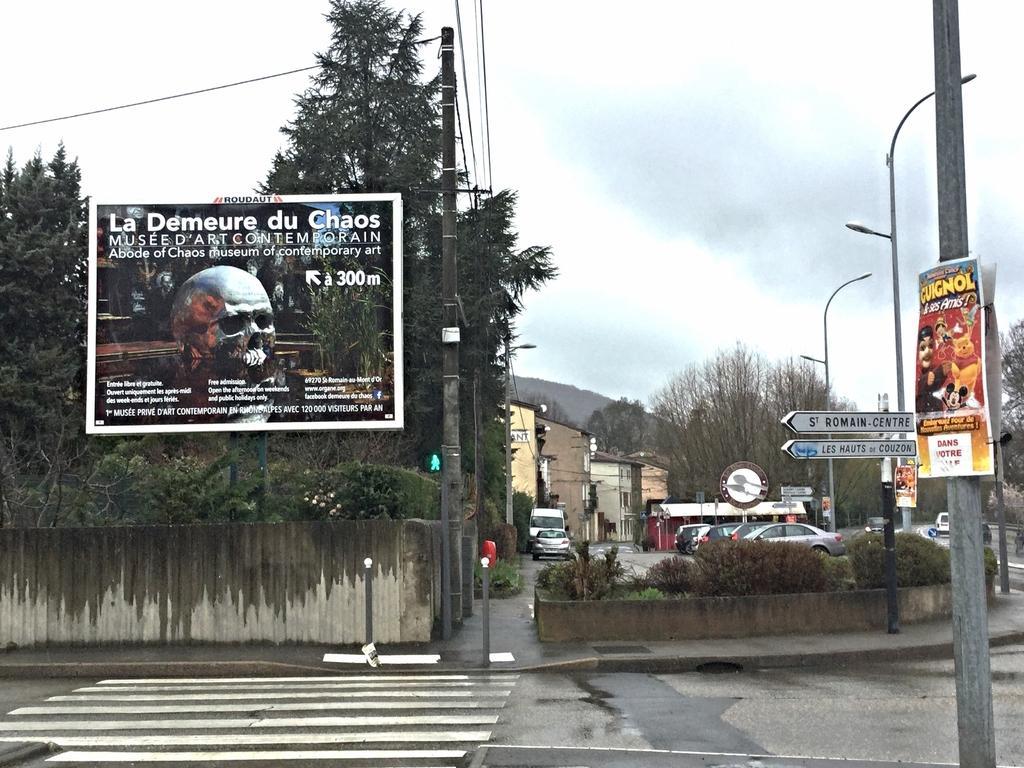Please provide a concise description of this image. In the image I can see a place houses, vehicles, poles to which there are some lights, boards and also I can see some trees and a banner to the side. 